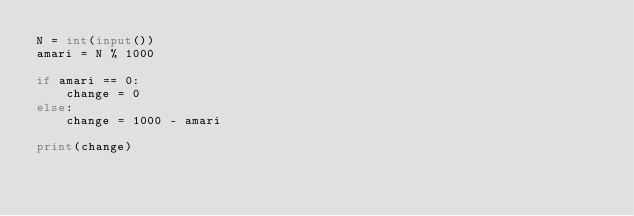<code> <loc_0><loc_0><loc_500><loc_500><_Python_>N = int(input())
amari = N % 1000

if amari == 0:
    change = 0
else:
    change = 1000 - amari

print(change)</code> 